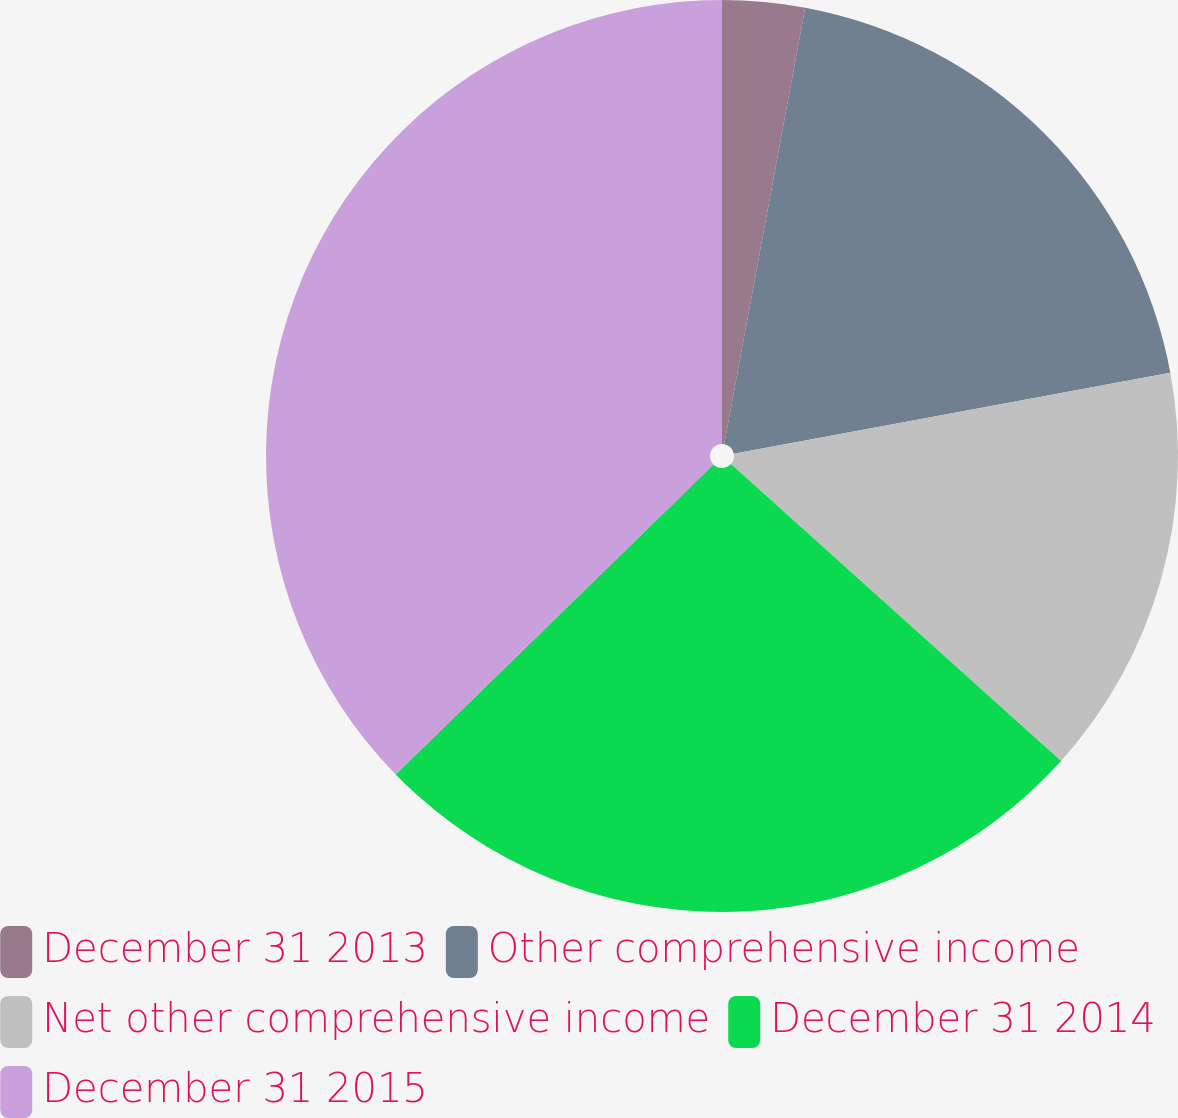<chart> <loc_0><loc_0><loc_500><loc_500><pie_chart><fcel>December 31 2013<fcel>Other comprehensive income<fcel>Net other comprehensive income<fcel>December 31 2014<fcel>December 31 2015<nl><fcel>2.92%<fcel>19.16%<fcel>14.58%<fcel>26.04%<fcel>37.31%<nl></chart> 